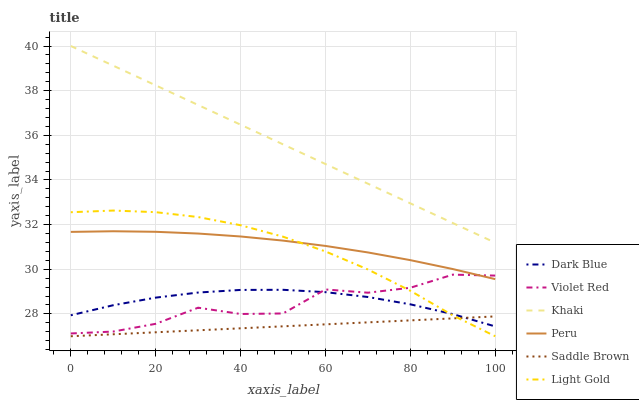Does Saddle Brown have the minimum area under the curve?
Answer yes or no. Yes. Does Khaki have the maximum area under the curve?
Answer yes or no. Yes. Does Dark Blue have the minimum area under the curve?
Answer yes or no. No. Does Dark Blue have the maximum area under the curve?
Answer yes or no. No. Is Khaki the smoothest?
Answer yes or no. Yes. Is Violet Red the roughest?
Answer yes or no. Yes. Is Dark Blue the smoothest?
Answer yes or no. No. Is Dark Blue the roughest?
Answer yes or no. No. Does Light Gold have the lowest value?
Answer yes or no. Yes. Does Dark Blue have the lowest value?
Answer yes or no. No. Does Khaki have the highest value?
Answer yes or no. Yes. Does Dark Blue have the highest value?
Answer yes or no. No. Is Dark Blue less than Peru?
Answer yes or no. Yes. Is Khaki greater than Peru?
Answer yes or no. Yes. Does Peru intersect Light Gold?
Answer yes or no. Yes. Is Peru less than Light Gold?
Answer yes or no. No. Is Peru greater than Light Gold?
Answer yes or no. No. Does Dark Blue intersect Peru?
Answer yes or no. No. 